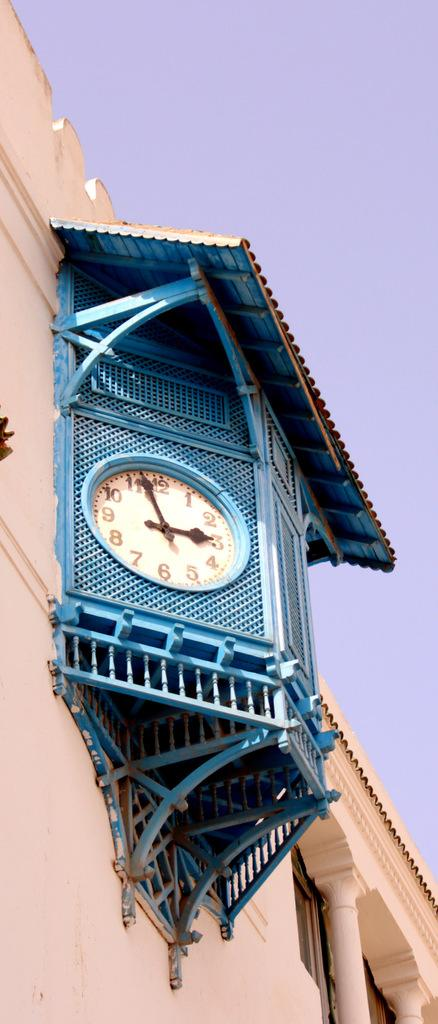Provide a one-sentence caption for the provided image. The time on a blue clock is very near to 3:00. 